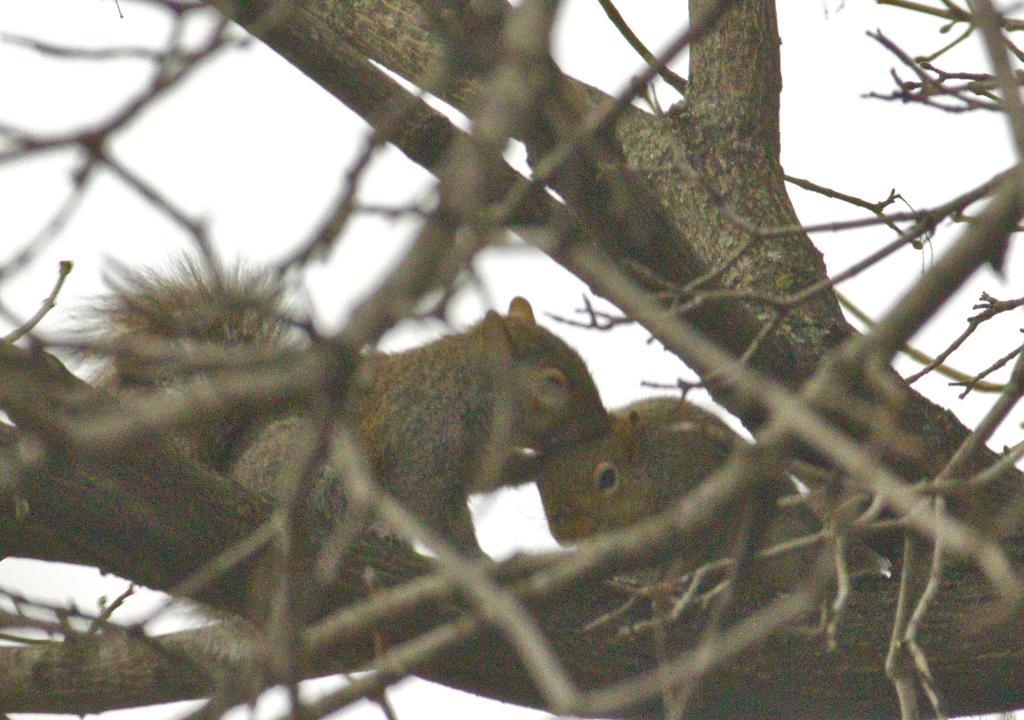Describe this image in one or two sentences. In this image we can see two squirrels on branch of a tree. In the background, we can see some trees and the sky. 